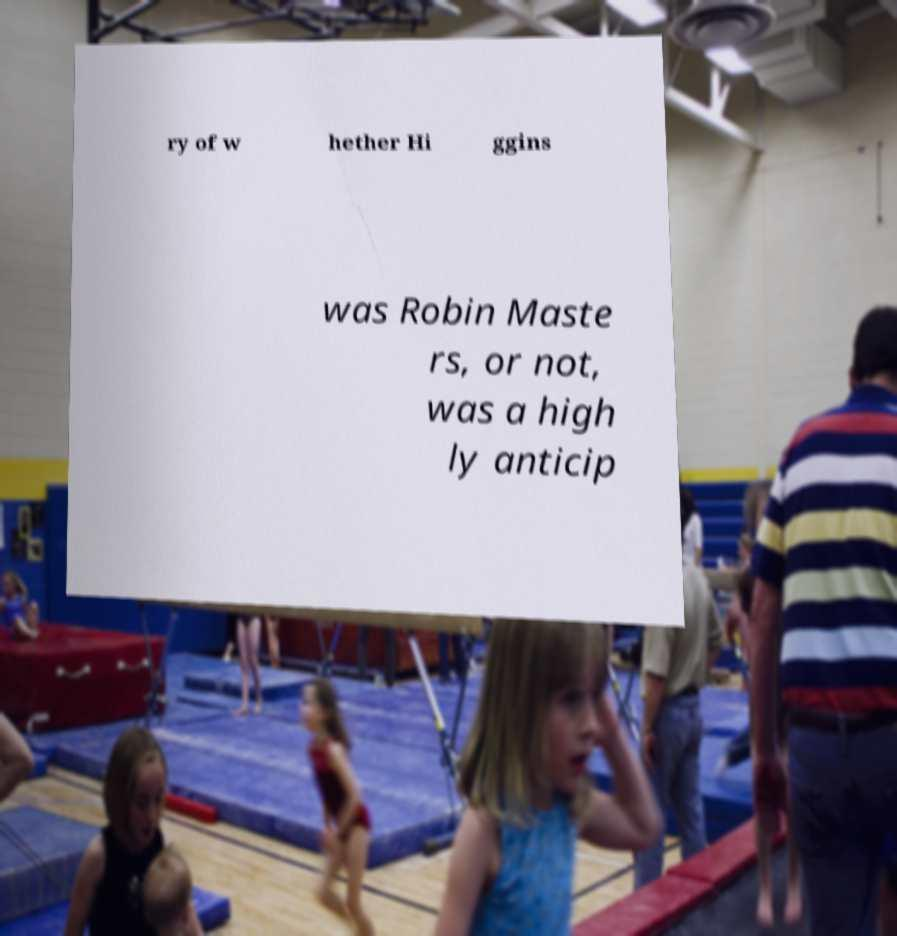Please read and relay the text visible in this image. What does it say? ry of w hether Hi ggins was Robin Maste rs, or not, was a high ly anticip 